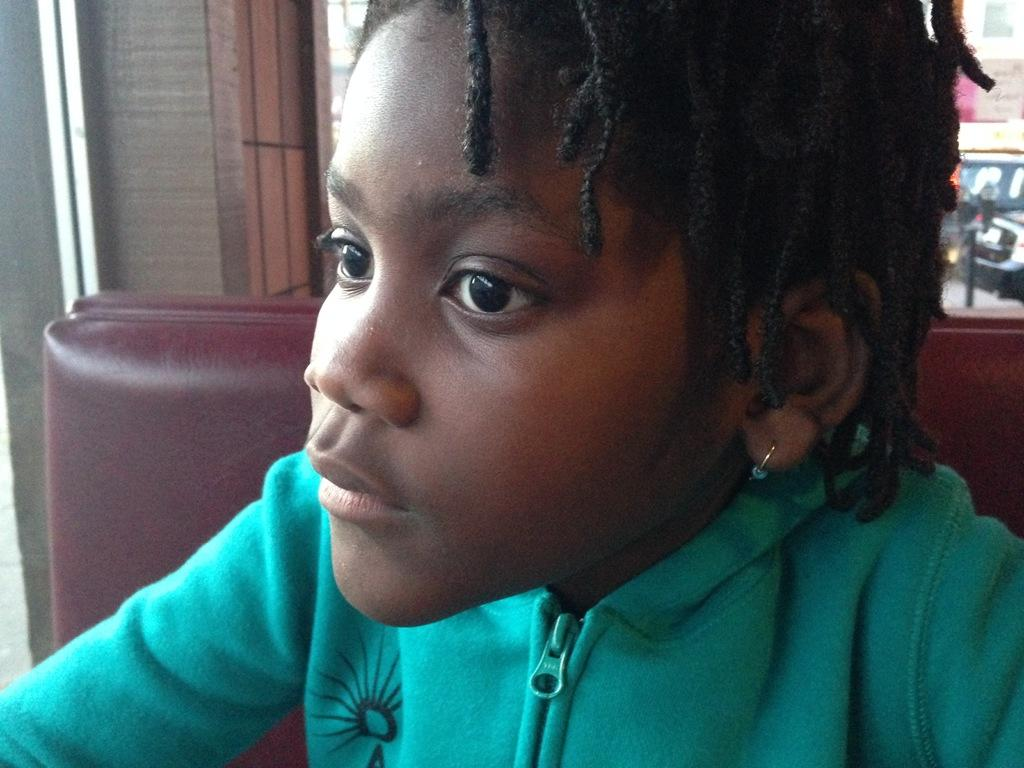Who is the main subject in the image? There is a girl in the image. What is the girl wearing? The girl is wearing a green jacket. What is the girl doing in the image? The girl is sitting on a chair. What can be seen in the background of the image? There are vehicles visible on a road and a building in the background. What type of writing can be seen on the girl's jacket in the image? There is no writing visible on the girl's jacket in the image. What type of business is being conducted in the background of the image? There is no indication of any business being conducted in the image; it only shows a girl sitting on a chair and a background with vehicles and a building. 